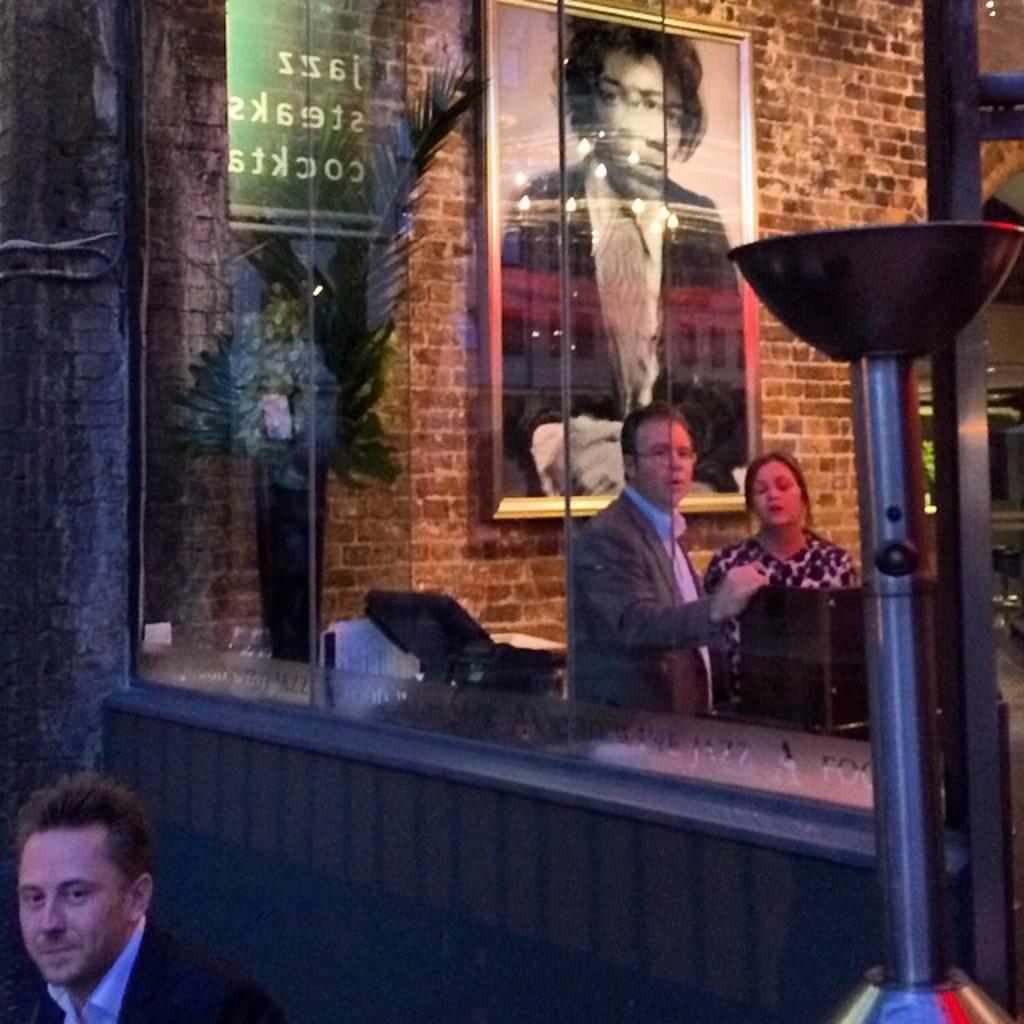Can you describe this image briefly? Here we can see three persons. There are glasses, plant, pole, and a frame. In the background there is a wall. 